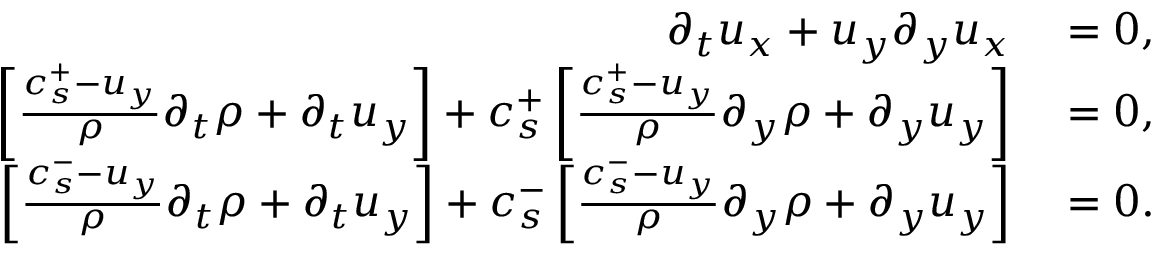<formula> <loc_0><loc_0><loc_500><loc_500>\begin{array} { r l } { \partial _ { t } u _ { x } + u _ { y } \partial _ { y } u _ { x } } & = 0 , } \\ { \left [ \frac { c _ { s } ^ { + } - u _ { y } } { \rho } \partial _ { t } \rho + \partial _ { t } u _ { y } \right ] + c _ { s } ^ { + } \left [ \frac { c _ { s } ^ { + } - u _ { y } } { \rho } \partial _ { y } \rho + \partial _ { y } u _ { y } \right ] } & = 0 , } \\ { \left [ \frac { c _ { s } ^ { - } - u _ { y } } { \rho } \partial _ { t } \rho + \partial _ { t } u _ { y } \right ] + c _ { s } ^ { - } \left [ \frac { c _ { s } ^ { - } - u _ { y } } { \rho } \partial _ { y } \rho + \partial _ { y } u _ { y } \right ] } & = 0 . } \end{array}</formula> 